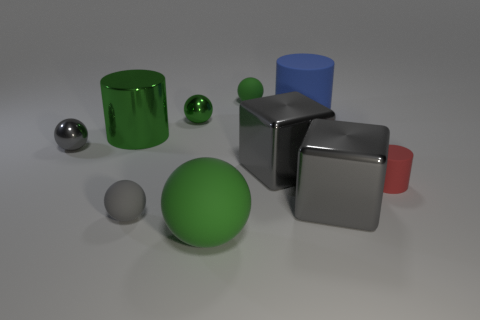Subtract all gray cubes. How many green balls are left? 3 Subtract all gray metal spheres. How many spheres are left? 4 Subtract all yellow balls. Subtract all blue cylinders. How many balls are left? 5 Subtract all cylinders. How many objects are left? 7 Subtract all large blue blocks. Subtract all large green rubber balls. How many objects are left? 9 Add 7 green metal things. How many green metal things are left? 9 Add 2 small gray metal spheres. How many small gray metal spheres exist? 3 Subtract 0 blue blocks. How many objects are left? 10 